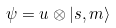Convert formula to latex. <formula><loc_0><loc_0><loc_500><loc_500>\psi = u \otimes | s , m \rangle</formula> 